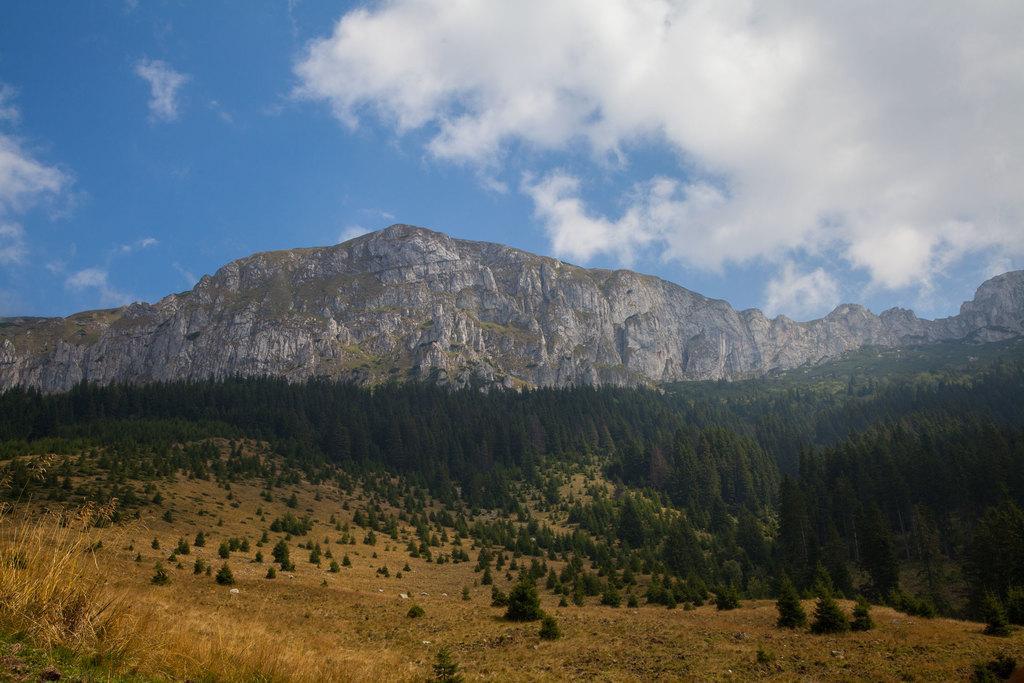Could you give a brief overview of what you see in this image? This image is taken outdoors. At the top of the image there is the sky with clouds. In the background there are many hills and rocks. At the bottom of the image there is a ground with grass on it. In the middle of the image there are many trees and plants with leaves, stems and branches. 